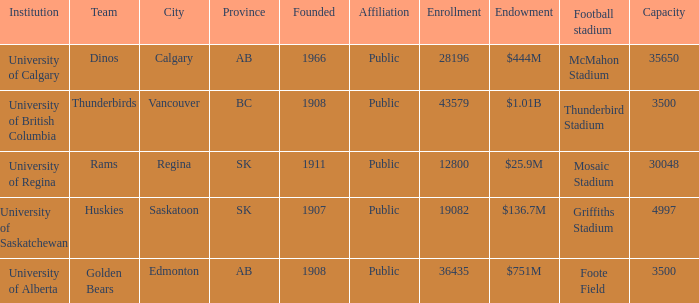What is the capacity for the  institution of university of alberta? 3500.0. 